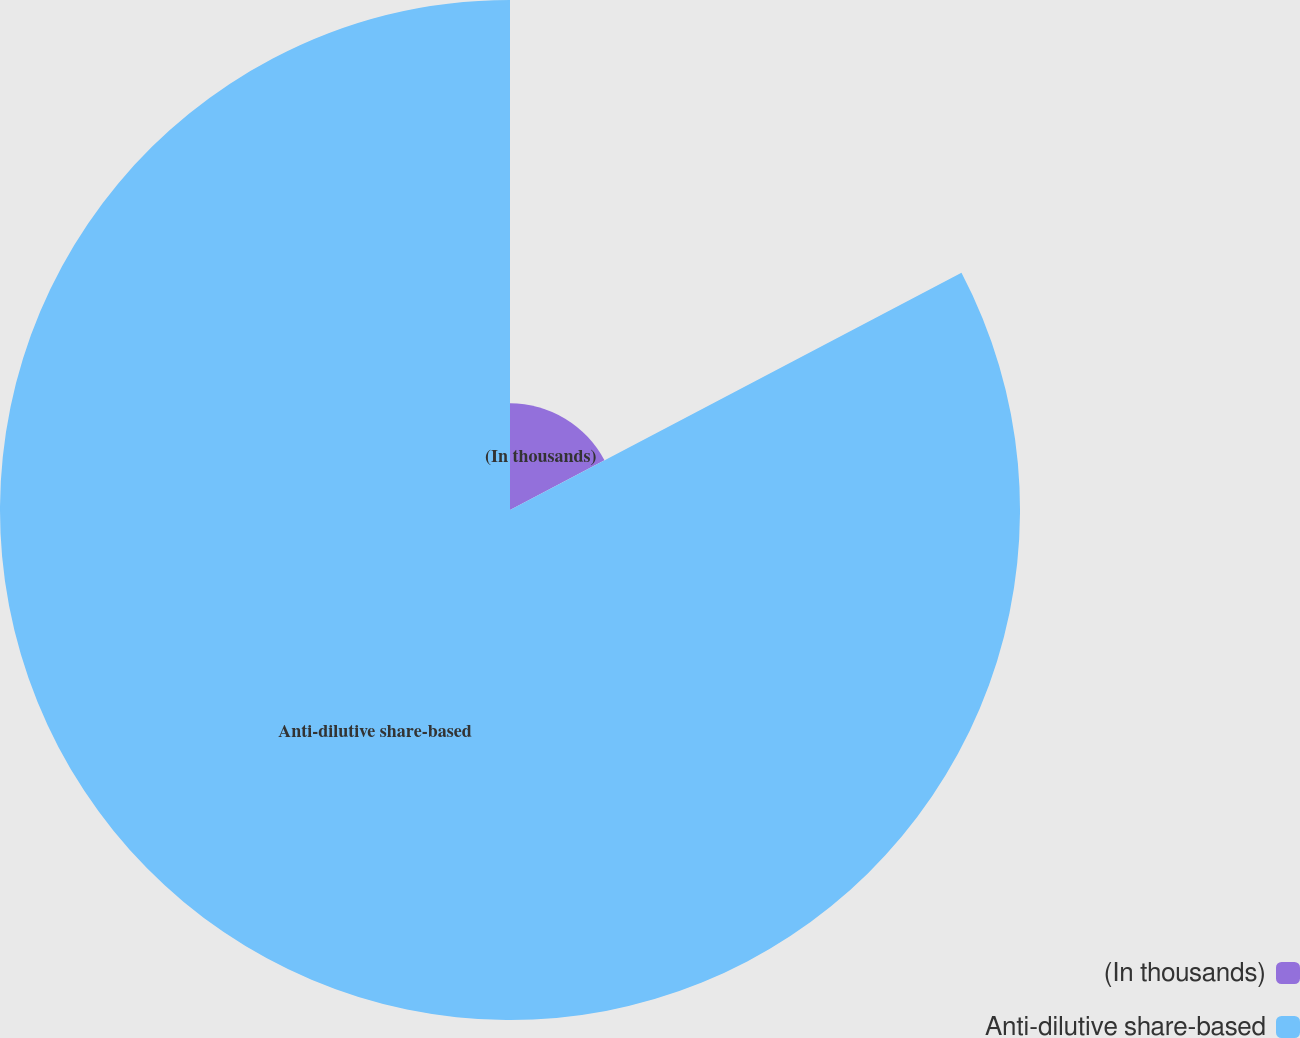Convert chart to OTSL. <chart><loc_0><loc_0><loc_500><loc_500><pie_chart><fcel>(In thousands)<fcel>Anti-dilutive share-based<nl><fcel>17.3%<fcel>82.7%<nl></chart> 